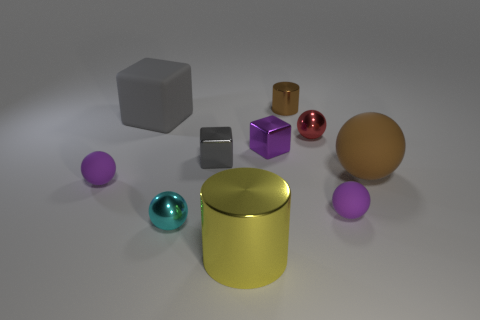There is a small cyan metal thing; how many metal things are in front of it? In front of the small cyan metal object, there appears to be one larger gold-colored cylindrical metal object. However, 'in front of' can depend on perspective, and based on this view, only the gold cylinder is directly in front of the cyan object. 